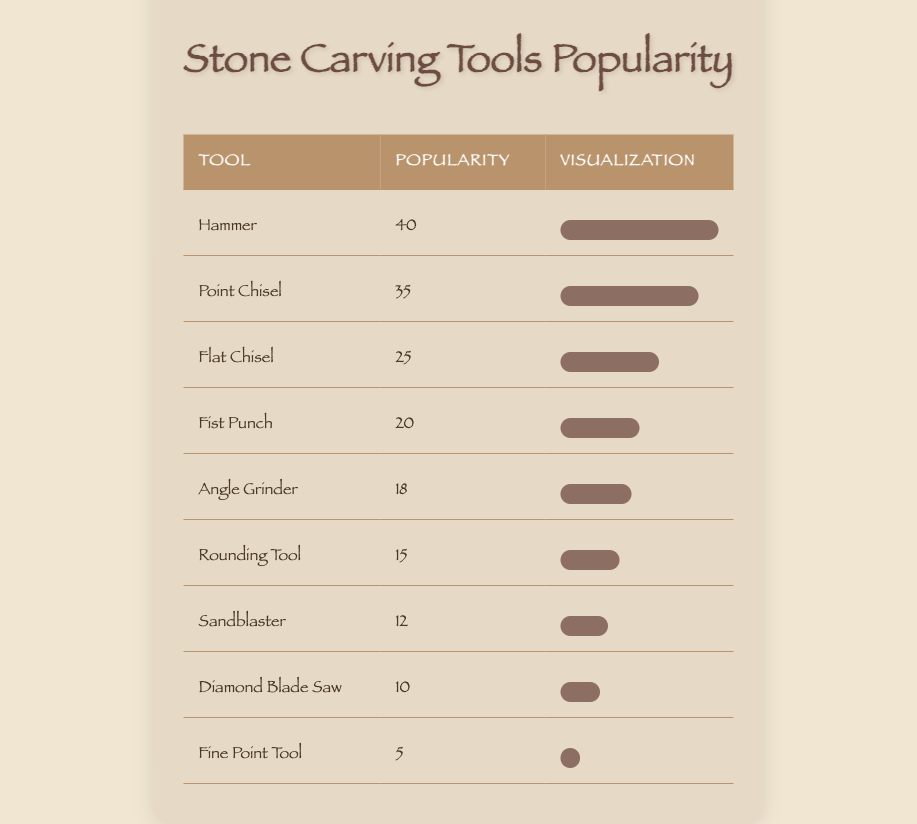What is the most popular stone carving tool? The most popular tool can be determined by looking for the highest value in the popularity column. The hammer has the highest popularity score of 40.
Answer: Hammer How many tools have a popularity score of 20 or higher? We count the tools with scores of 20 and above: Hammer (40), Point Chisel (35), Flat Chisel (25), Fist Punch (20). There are 4 tools in total.
Answer: 4 What is the difference in popularity between the Point Chisel and the Flat Chisel? The Point Chisel has a popularity of 35 and the Flat Chisel has a popularity of 25. The difference is 35 - 25 = 10.
Answer: 10 Is the Diamond Blade Saw more popular than the Fine Point Tool? The Diamond Blade Saw has a popularity score of 10, and the Fine Point Tool has a score of 5. Since 10 is greater than 5, the statement is true.
Answer: Yes What is the average popularity score of all stone carving tools? To find the average, we first sum the popularity scores: 40 + 35 + 25 + 20 + 18 + 15 + 12 + 10 + 5 = 175. Then, we divide by the number of tools (9) to get the average: 175/9 = approximately 19.44.
Answer: 19.44 